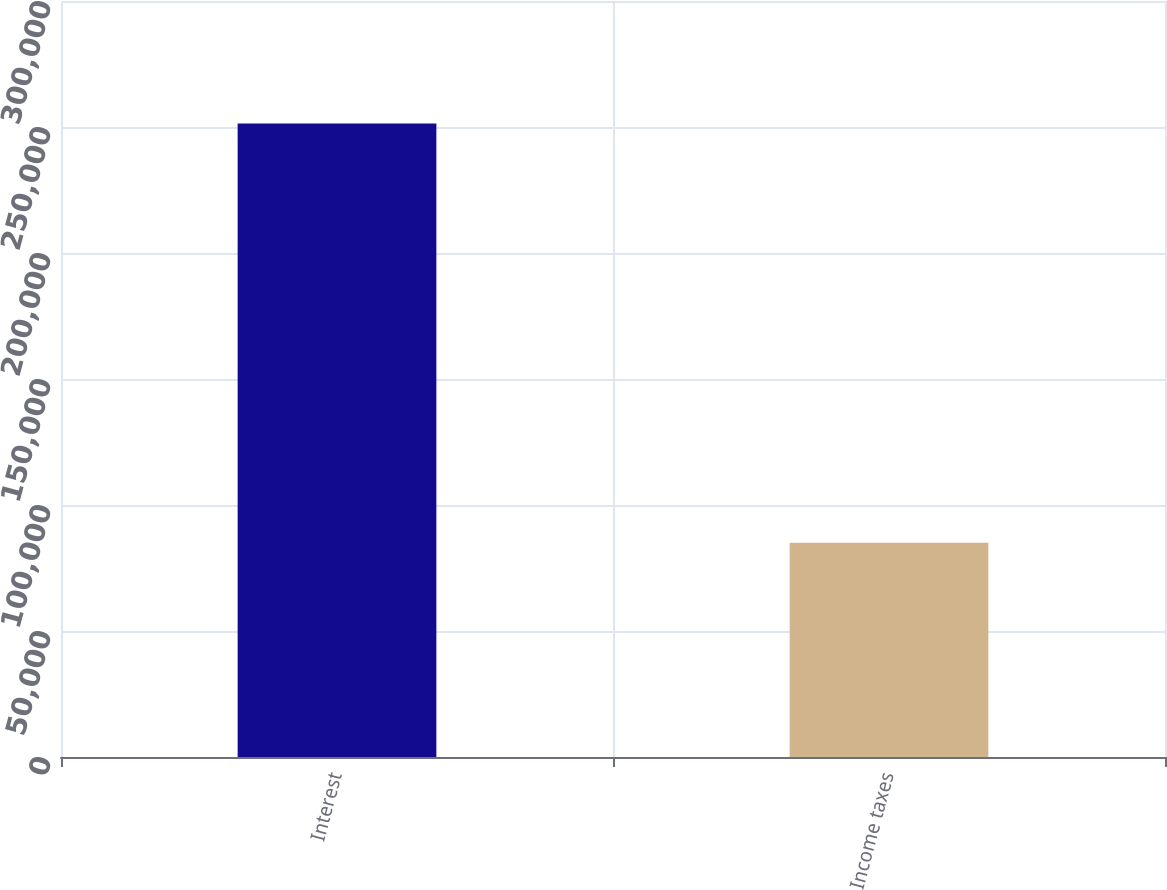Convert chart. <chart><loc_0><loc_0><loc_500><loc_500><bar_chart><fcel>Interest<fcel>Income taxes<nl><fcel>251341<fcel>84984<nl></chart> 